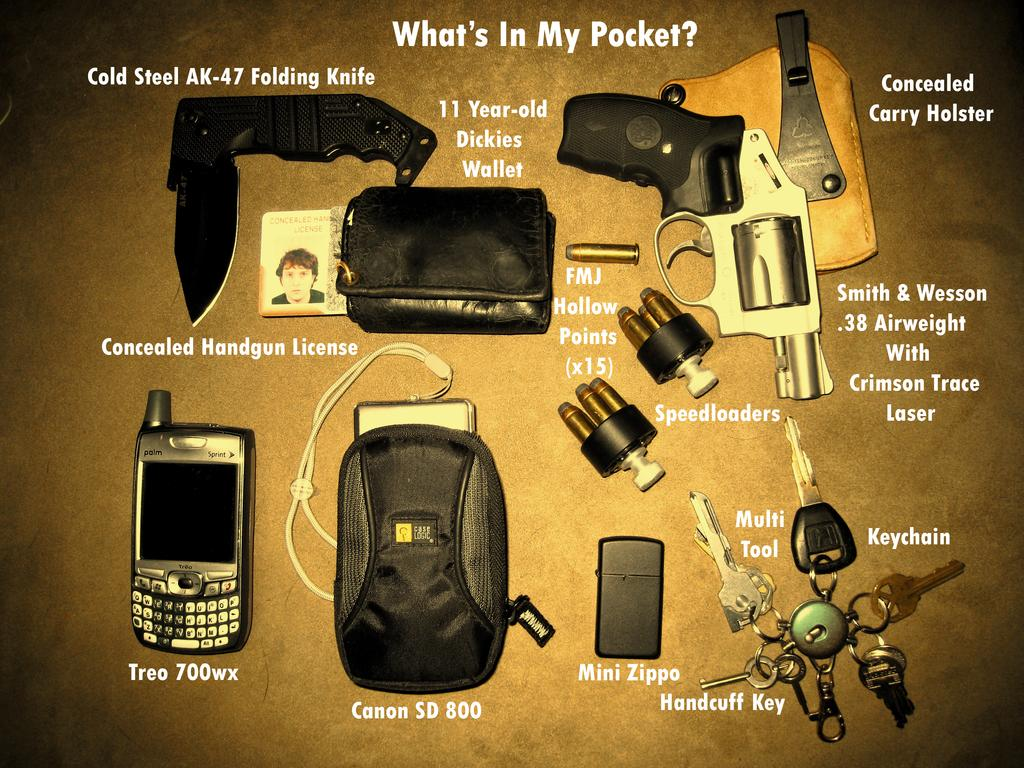<image>
Create a compact narrative representing the image presented. A display of items that someone has labeled "What's in My Pocket?" 